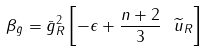Convert formula to latex. <formula><loc_0><loc_0><loc_500><loc_500>\beta _ { \bar { g } } = { \bar { g } } _ { R } ^ { 2 } \left [ - \epsilon + \frac { n + 2 } { 3 } \ \widetilde { u } _ { R } \right ]</formula> 